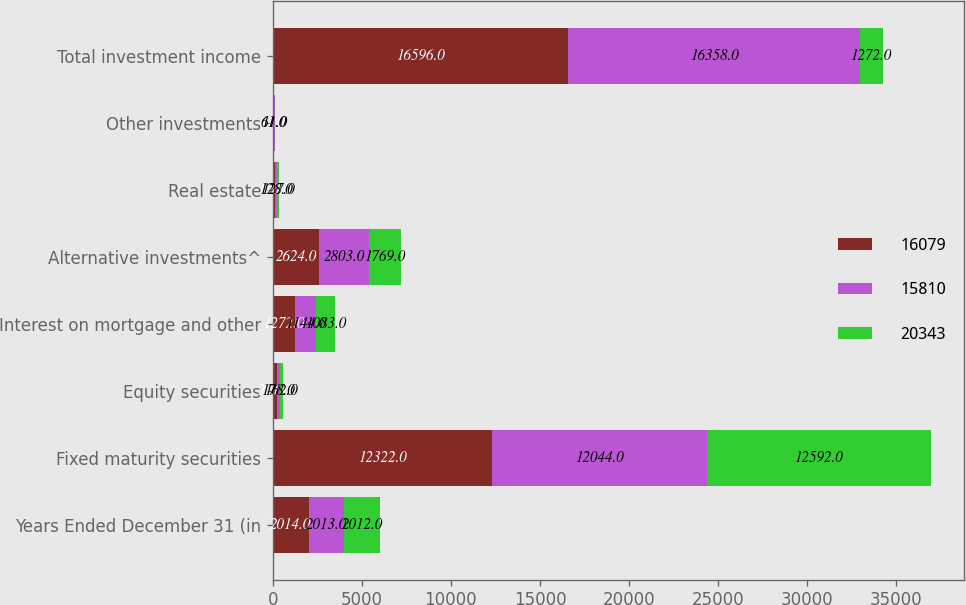<chart> <loc_0><loc_0><loc_500><loc_500><stacked_bar_chart><ecel><fcel>Years Ended December 31 (in<fcel>Fixed maturity securities<fcel>Equity securities<fcel>Interest on mortgage and other<fcel>Alternative investments^<fcel>Real estate<fcel>Other investments<fcel>Total investment income<nl><fcel>16079<fcel>2014<fcel>12322<fcel>221<fcel>1272<fcel>2624<fcel>110<fcel>47<fcel>16596<nl><fcel>15810<fcel>2013<fcel>12044<fcel>178<fcel>1144<fcel>2803<fcel>128<fcel>61<fcel>16358<nl><fcel>20343<fcel>2012<fcel>12592<fcel>162<fcel>1083<fcel>1769<fcel>127<fcel>11<fcel>1272<nl></chart> 